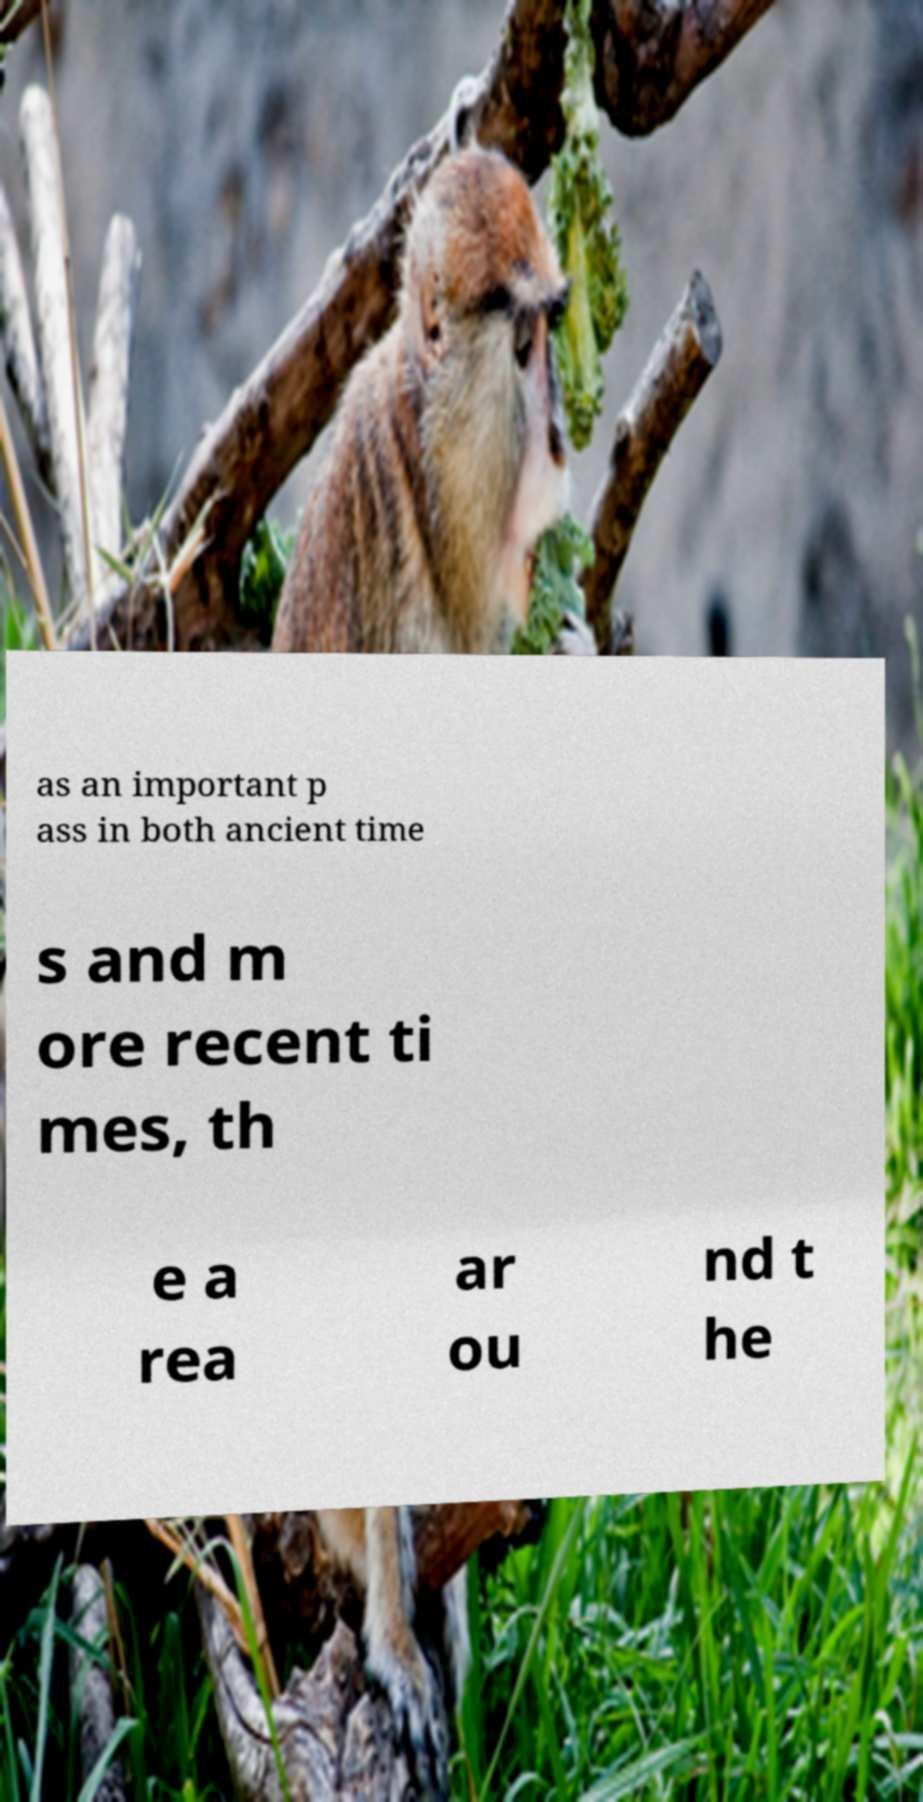There's text embedded in this image that I need extracted. Can you transcribe it verbatim? as an important p ass in both ancient time s and m ore recent ti mes, th e a rea ar ou nd t he 